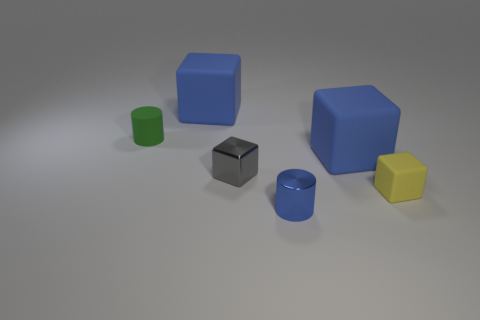Subtract all brown cubes. Subtract all purple spheres. How many cubes are left? 4 Add 3 large objects. How many objects exist? 9 Subtract all cubes. How many objects are left? 2 Add 6 tiny yellow matte things. How many tiny yellow matte things exist? 7 Subtract 0 blue spheres. How many objects are left? 6 Subtract all tiny brown metallic objects. Subtract all tiny gray shiny objects. How many objects are left? 5 Add 3 blue rubber things. How many blue rubber things are left? 5 